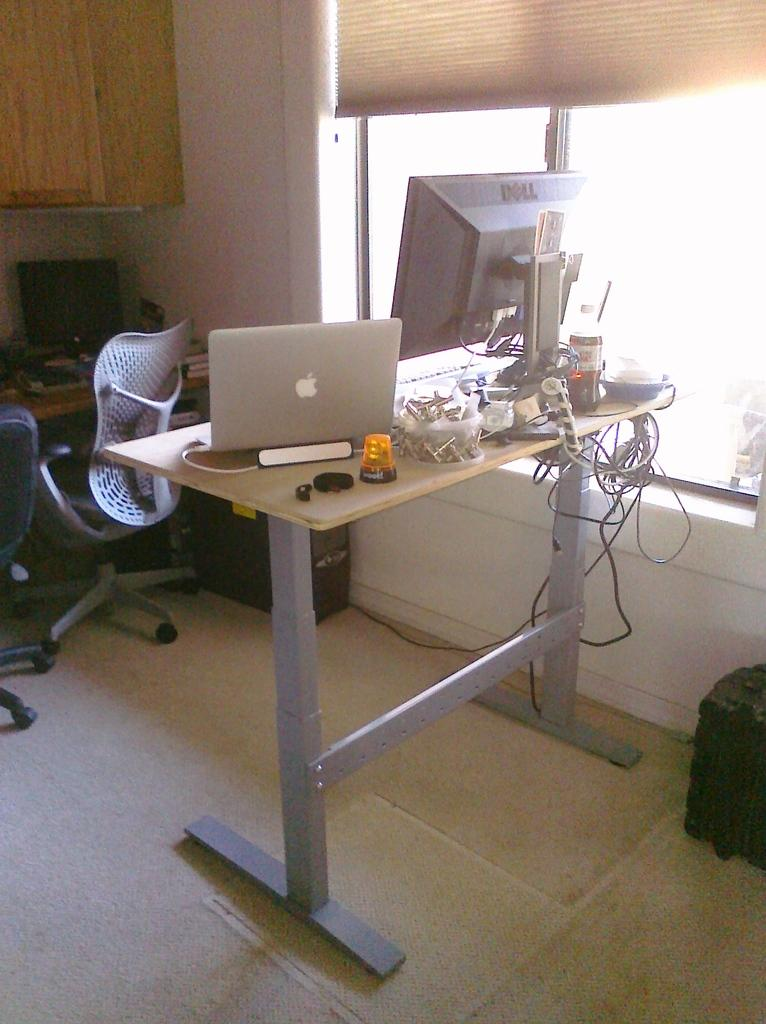What is on the floor in the image? There is a table on the floor in the image. What is on the table? There is a system on the table, along with other objects. What type of furniture is in the image? There is a chair in the image. What can be seen through the window? The facts provided do not mention anything about the window, so we cannot determine what can be seen through it. What type of tin can be seen on the table? There is no tin present on the table in the image. What type of plastic is used for the chair? There is no plastic mentioned or visible in the image. 